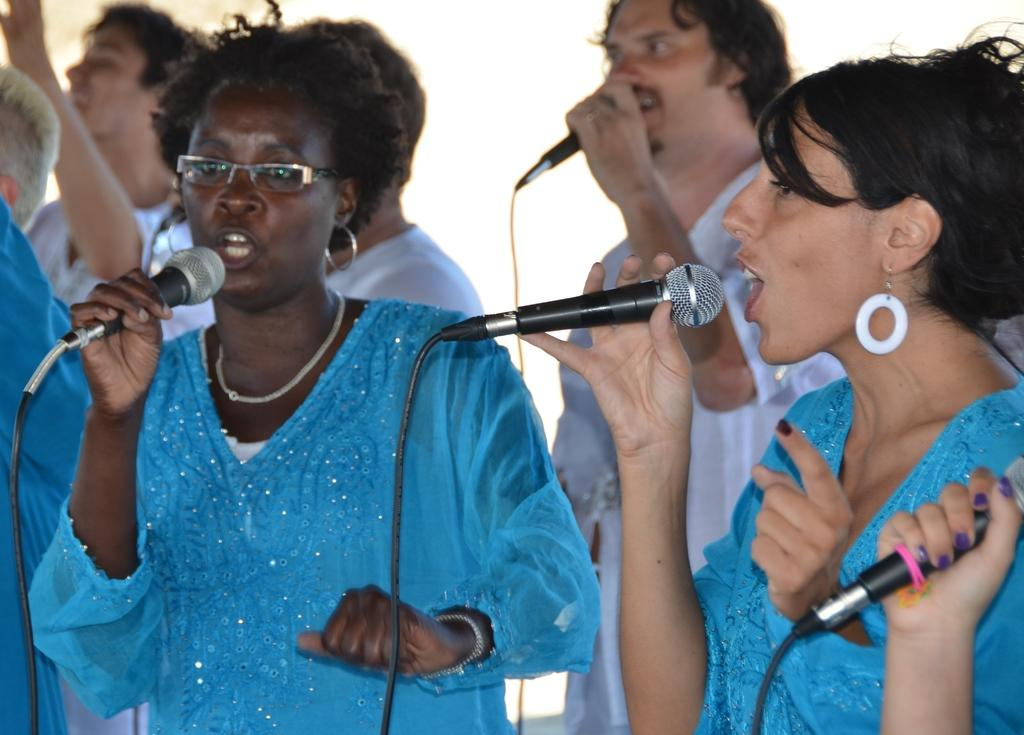How many people are in the image? There are three people in the image: two ladies and one guy. What are the ladies wearing in the image? The ladies are wearing blue dresses in the image. What are the ladies holding in the image? The ladies are holding microphones in the image. What is the guy wearing in the image? The guy is wearing a white dress in the image. What is the guy holding in the image? The guy is holding a microphone in the image. What type of snake can be seen slithering around the ladies' feet in the image? There is no snake present in the image; the ladies and the guy are holding microphones. What committee is the guy representing in the image? There is no committee mentioned or depicted in the image. 